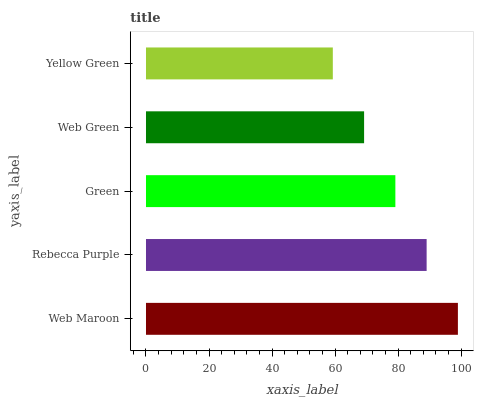Is Yellow Green the minimum?
Answer yes or no. Yes. Is Web Maroon the maximum?
Answer yes or no. Yes. Is Rebecca Purple the minimum?
Answer yes or no. No. Is Rebecca Purple the maximum?
Answer yes or no. No. Is Web Maroon greater than Rebecca Purple?
Answer yes or no. Yes. Is Rebecca Purple less than Web Maroon?
Answer yes or no. Yes. Is Rebecca Purple greater than Web Maroon?
Answer yes or no. No. Is Web Maroon less than Rebecca Purple?
Answer yes or no. No. Is Green the high median?
Answer yes or no. Yes. Is Green the low median?
Answer yes or no. Yes. Is Rebecca Purple the high median?
Answer yes or no. No. Is Web Maroon the low median?
Answer yes or no. No. 